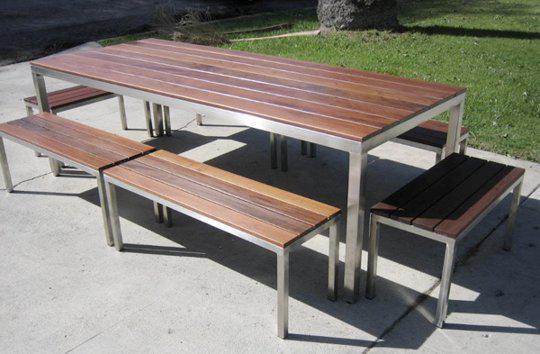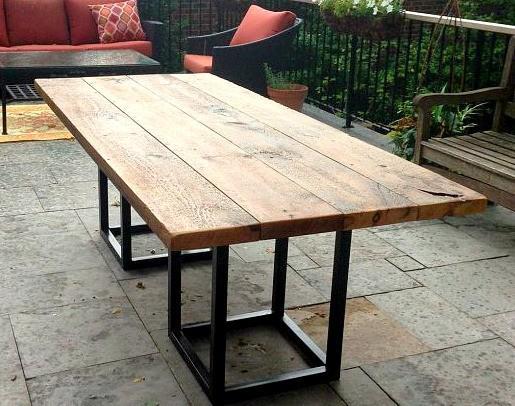The first image is the image on the left, the second image is the image on the right. Assess this claim about the two images: "In one image, a rectangular wooden table has two long bench seats, one on each side.". Correct or not? Answer yes or no. No. The first image is the image on the left, the second image is the image on the right. Considering the images on both sides, is "There is a concrete floor visible." valid? Answer yes or no. Yes. 